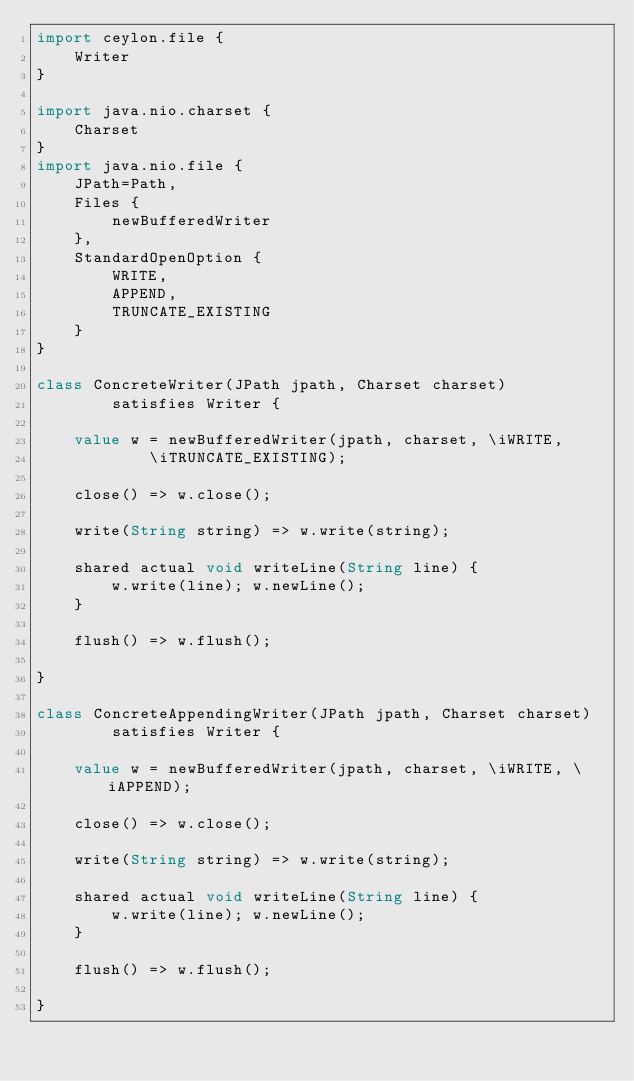Convert code to text. <code><loc_0><loc_0><loc_500><loc_500><_Ceylon_>import ceylon.file {
    Writer
}

import java.nio.charset {
    Charset
}
import java.nio.file {
    JPath=Path,
    Files {
        newBufferedWriter
    },
    StandardOpenOption {
        WRITE,
        APPEND,
        TRUNCATE_EXISTING
    }
}

class ConcreteWriter(JPath jpath, Charset charset) 
        satisfies Writer {
    
    value w = newBufferedWriter(jpath, charset, \iWRITE, 
            \iTRUNCATE_EXISTING);
    
    close() => w.close();
    
    write(String string) => w.write(string);
    
    shared actual void writeLine(String line) {
        w.write(line); w.newLine();
    }
    
    flush() => w.flush();
    
}

class ConcreteAppendingWriter(JPath jpath, Charset charset) 
        satisfies Writer {
    
    value w = newBufferedWriter(jpath, charset, \iWRITE, \iAPPEND);
    
    close() => w.close();
    
    write(String string) => w.write(string);
    
    shared actual void writeLine(String line) {
        w.write(line); w.newLine();
    }
    
    flush() => w.flush();
    
}
</code> 